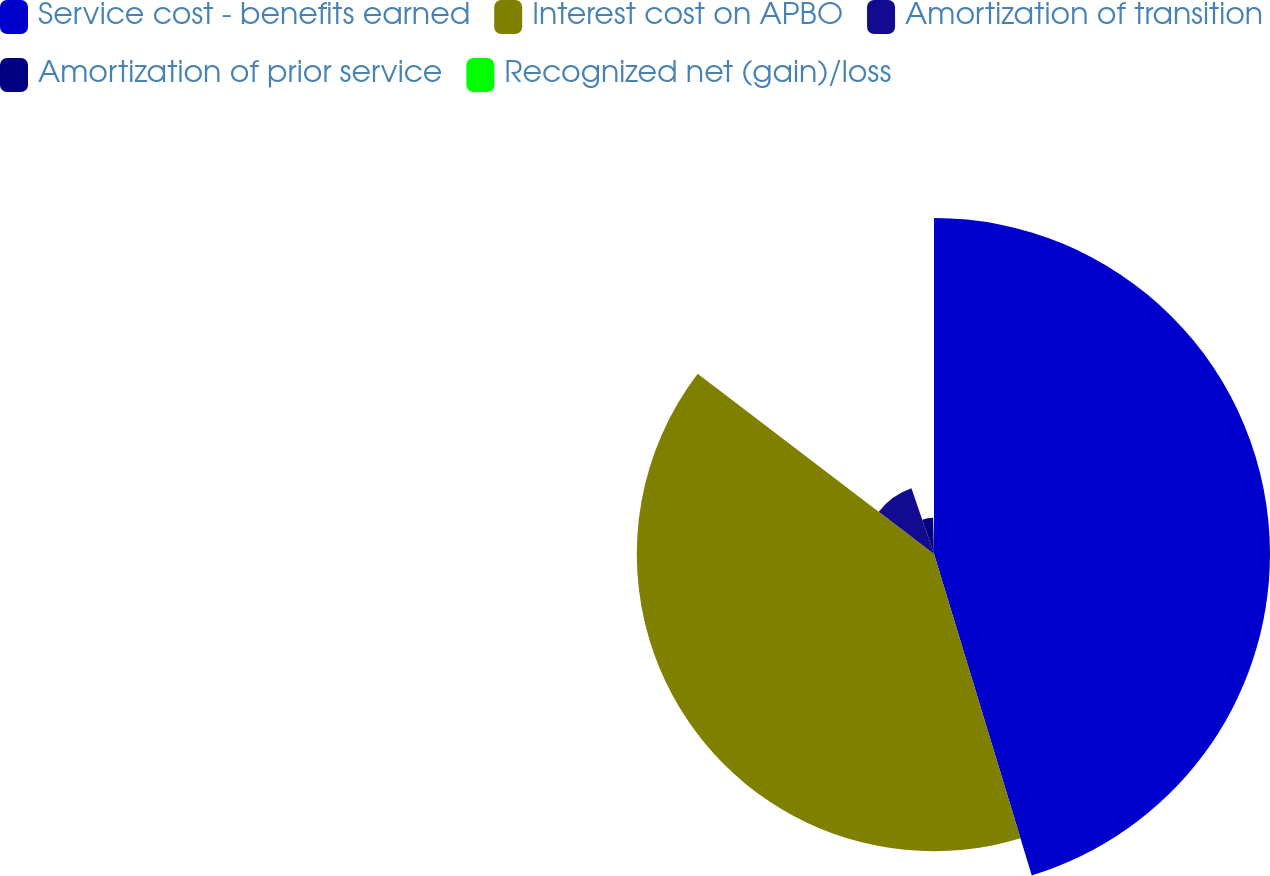<chart> <loc_0><loc_0><loc_500><loc_500><pie_chart><fcel>Service cost - benefits earned<fcel>Interest cost on APBO<fcel>Amortization of transition<fcel>Amortization of prior service<fcel>Recognized net (gain)/loss<nl><fcel>45.3%<fcel>40.07%<fcel>9.37%<fcel>4.88%<fcel>0.38%<nl></chart> 